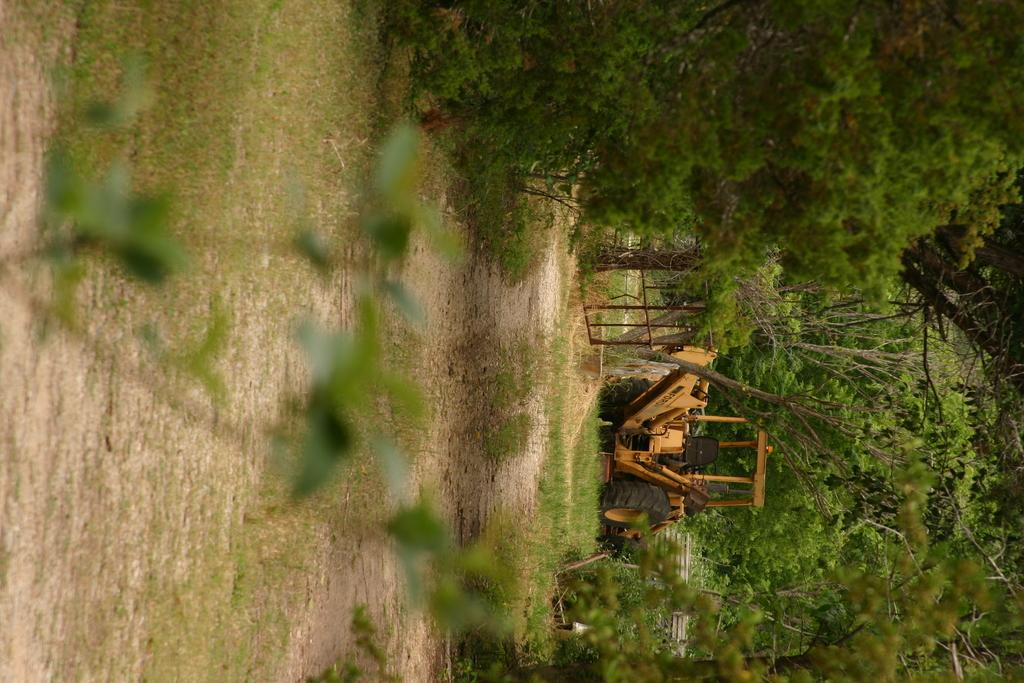What type of plant is on the ground in the image? There is a plant with green leaves on the ground. What else is on the ground in the image? There is grass on the ground. What can be seen in the background of the image? There are trees in the background. What is the location of the excavator in the image? The excavator is in the background on the grass. How many nuts are being carried by the sheep in the image? There are no sheep or nuts present in the image. What type of street can be seen in the image? There is no street visible in the image. 